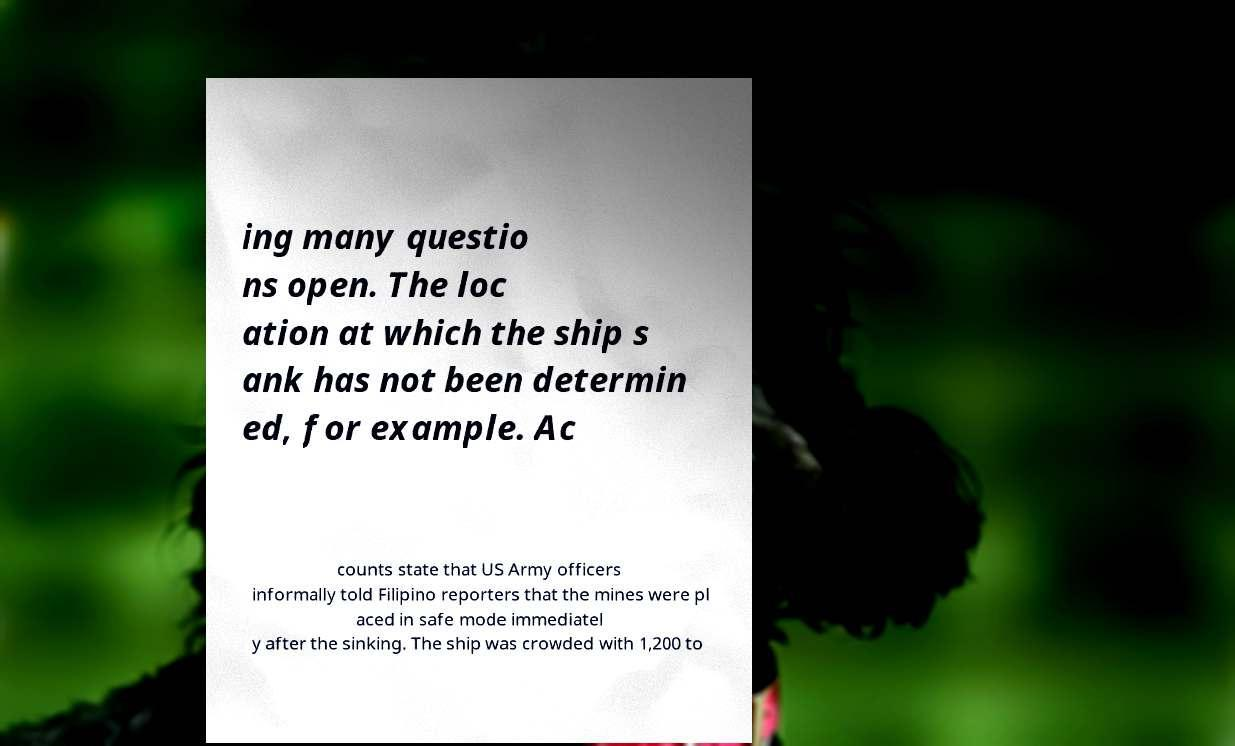Could you assist in decoding the text presented in this image and type it out clearly? ing many questio ns open. The loc ation at which the ship s ank has not been determin ed, for example. Ac counts state that US Army officers informally told Filipino reporters that the mines were pl aced in safe mode immediatel y after the sinking. The ship was crowded with 1,200 to 